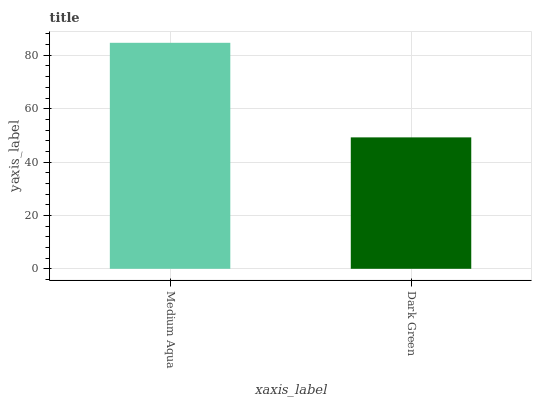Is Dark Green the minimum?
Answer yes or no. Yes. Is Medium Aqua the maximum?
Answer yes or no. Yes. Is Dark Green the maximum?
Answer yes or no. No. Is Medium Aqua greater than Dark Green?
Answer yes or no. Yes. Is Dark Green less than Medium Aqua?
Answer yes or no. Yes. Is Dark Green greater than Medium Aqua?
Answer yes or no. No. Is Medium Aqua less than Dark Green?
Answer yes or no. No. Is Medium Aqua the high median?
Answer yes or no. Yes. Is Dark Green the low median?
Answer yes or no. Yes. Is Dark Green the high median?
Answer yes or no. No. Is Medium Aqua the low median?
Answer yes or no. No. 